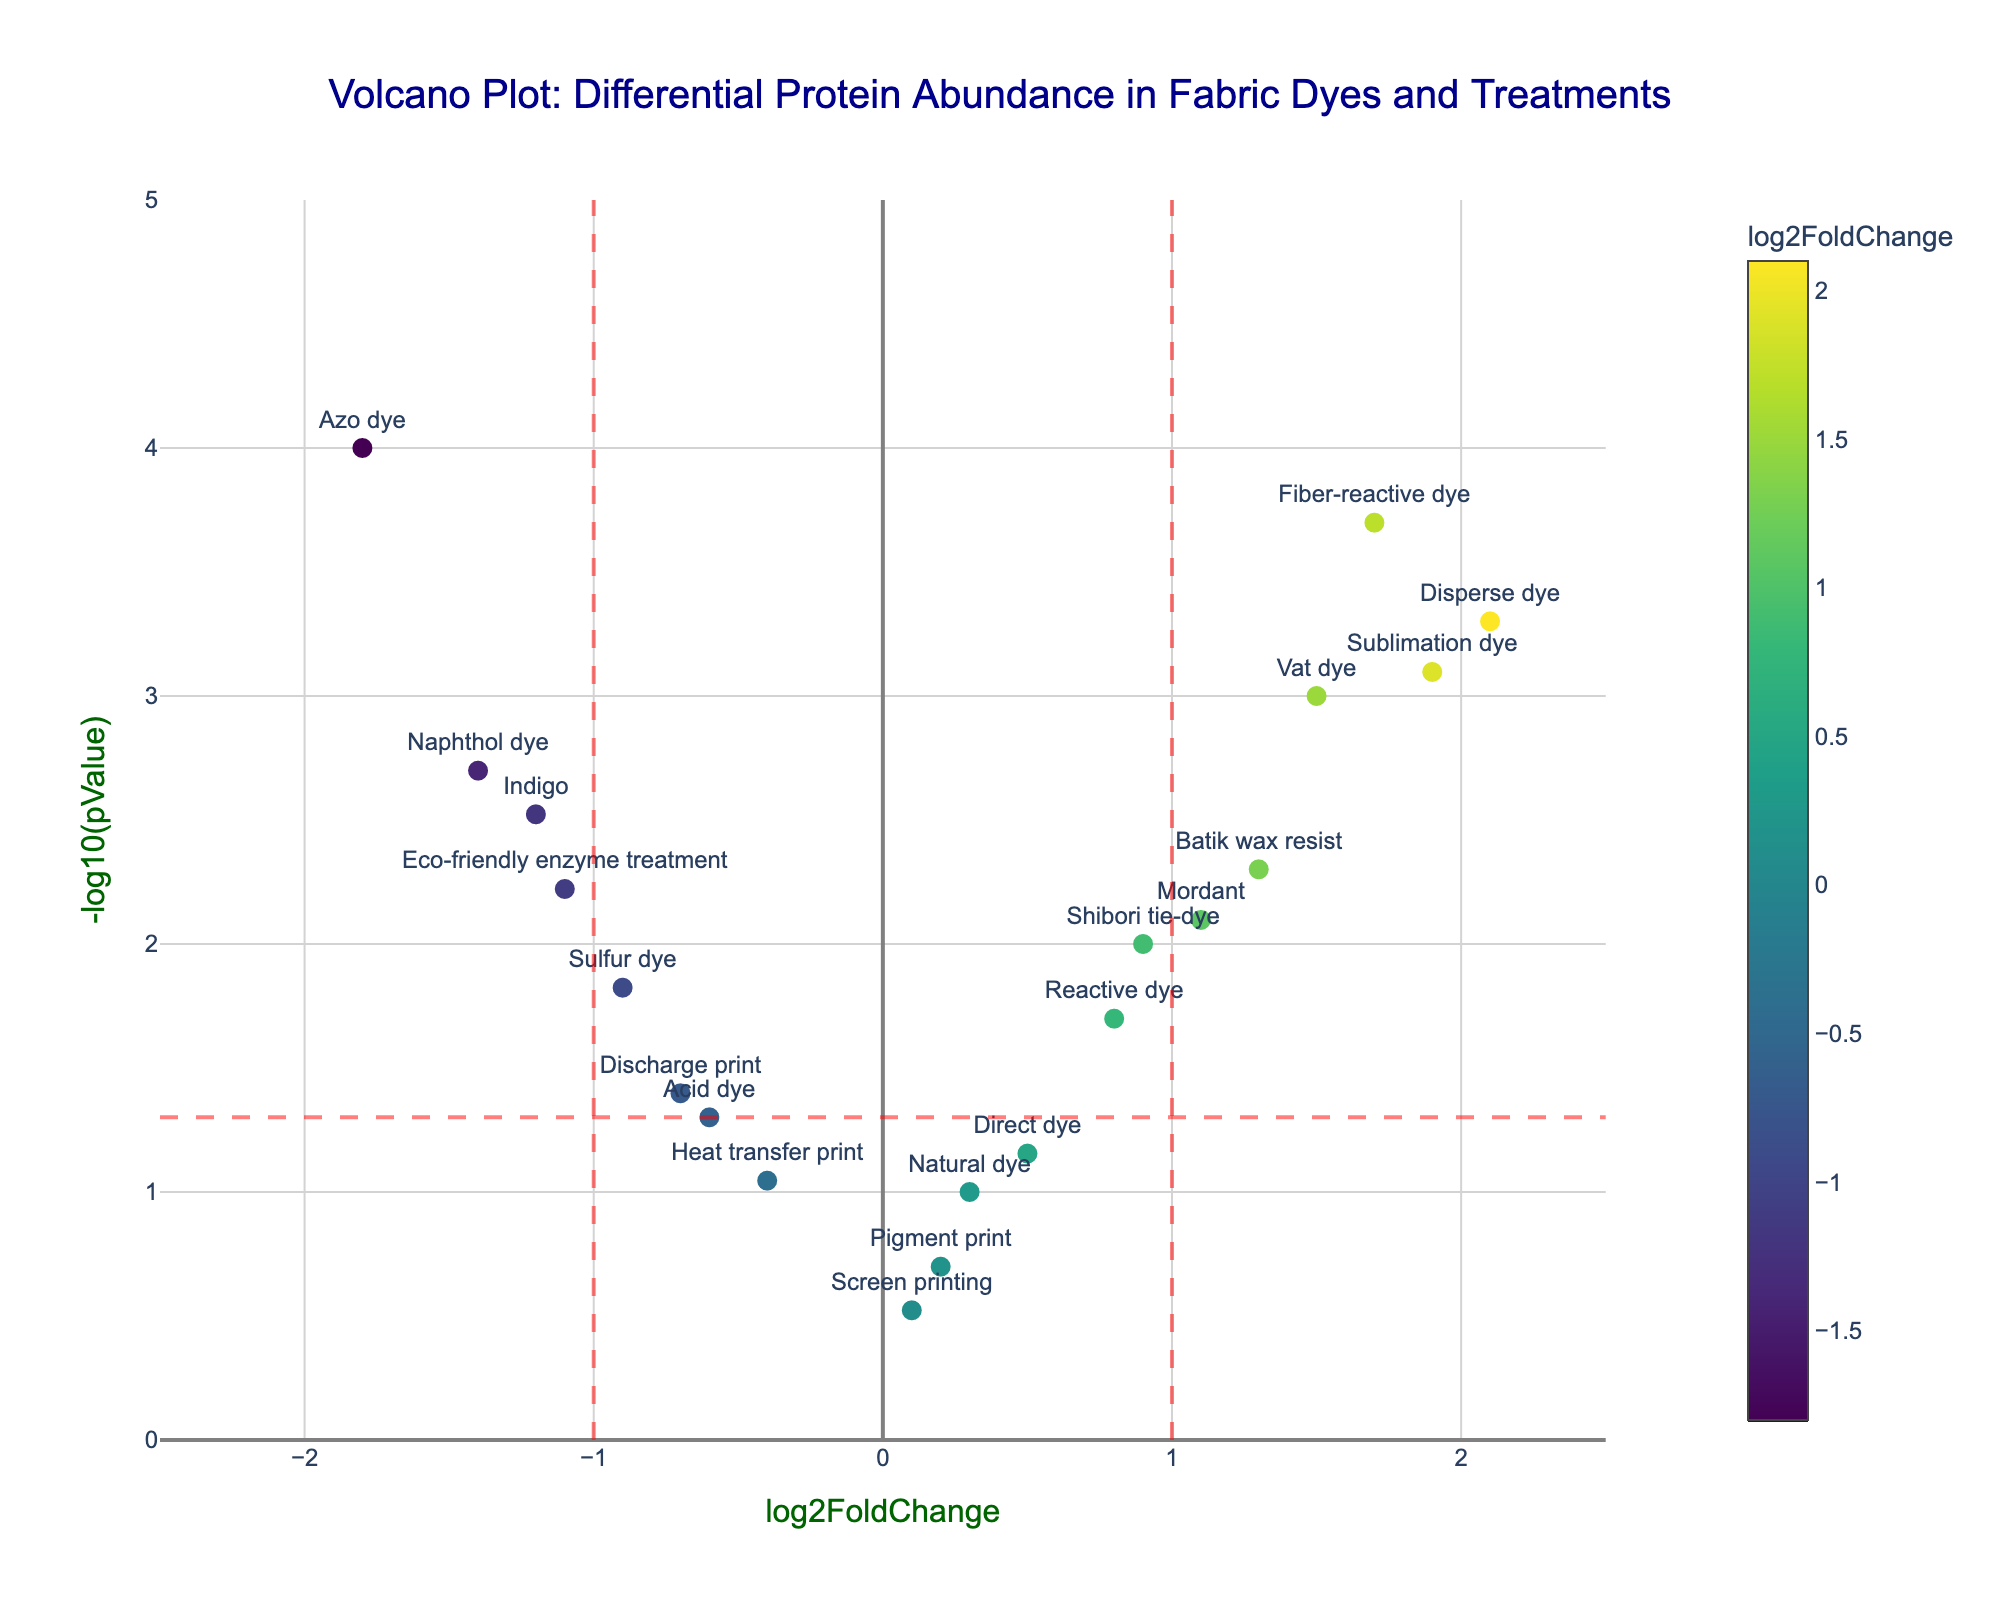Which data point represents the highest negative log2FoldChange? By referring to the x-axis and looking for the leftmost point, we see the data point labeled as Azo dye has the highest negative log2FoldChange.
Answer: Azo dye What is the p-value for the fiber-reactive dye? The y-axis shows -log10(pValue). The fiber-reactive dye has a value near 3.7 on the y-axis. Converting this to a p-value: p-value = 10^(-3.7) ≈ 0.0002.
Answer: 0.0002 How many data points have a p-value less than 0.05? Data points below the red dashed horizontal line at -log10(0.05) ≈ 1.3 on the y-axis have p-values less than 0.05. Counting those above this threshold, there are 15 such points.
Answer: 15 Which fabric dye shows the highest positive log2FoldChange and what is its significance? The data point with the highest positive log2FoldChange is Disperse dye on the rightmost side of the plot. Its y-axis value indicates a p-value of 0.0005, which is significant (p-value< 0.05).
Answer: Disperse dye, significant (p-value = 0.0005) Are there any dyes or treatments with non-significant differential protein abundance? Non-significant data points lie below the red dashed horizontal line at -log10(0.05) ≈ 1.3. Notable ones include Natural dye, Direct dye, Pigment print, Screen printing, and Heat transfer print.
Answer: Yes Compare the log2FoldChange values for Mordant and Shibori tie-dye. Which is greater? Mordant and Shibori tie-dye's log2FoldChange values can be compared on the x-axis. Mordant is at around 1.1, while Shibori tie-dye is at 0.9.
Answer: Mordant What is the significance threshold indicated by the horizontal red dashed line? The horizontal red dashed line is at -log10(0.05), which is approximately 1.3 on the y-axis. This represents the significance threshold for p-values.
Answer: 0.05 How do the log2FoldChange values for Acid dye and Sulfur dye compare? Acid dye has a log2FoldChange of -0.6 and Sulfur dye has -0.9, indicating that Sulfur dye has a more negative log2FoldChange.
Answer: Sulfur dye Which treatments are located outside the thresholds indicated by the vertical red dashed lines? These lines are at log2FoldChange = ±1. Data points outside these limits (>-1 and <1) include Vat dye, Mordant, Batik wax resist, Shibori tie-dye, Sublimation dye, and Fiber-reactive dye.
Answer: Vat dye, Mordant, Batik wax resist, Shibori tie-dye, Sublimation dye, Fiber-reactive dye 